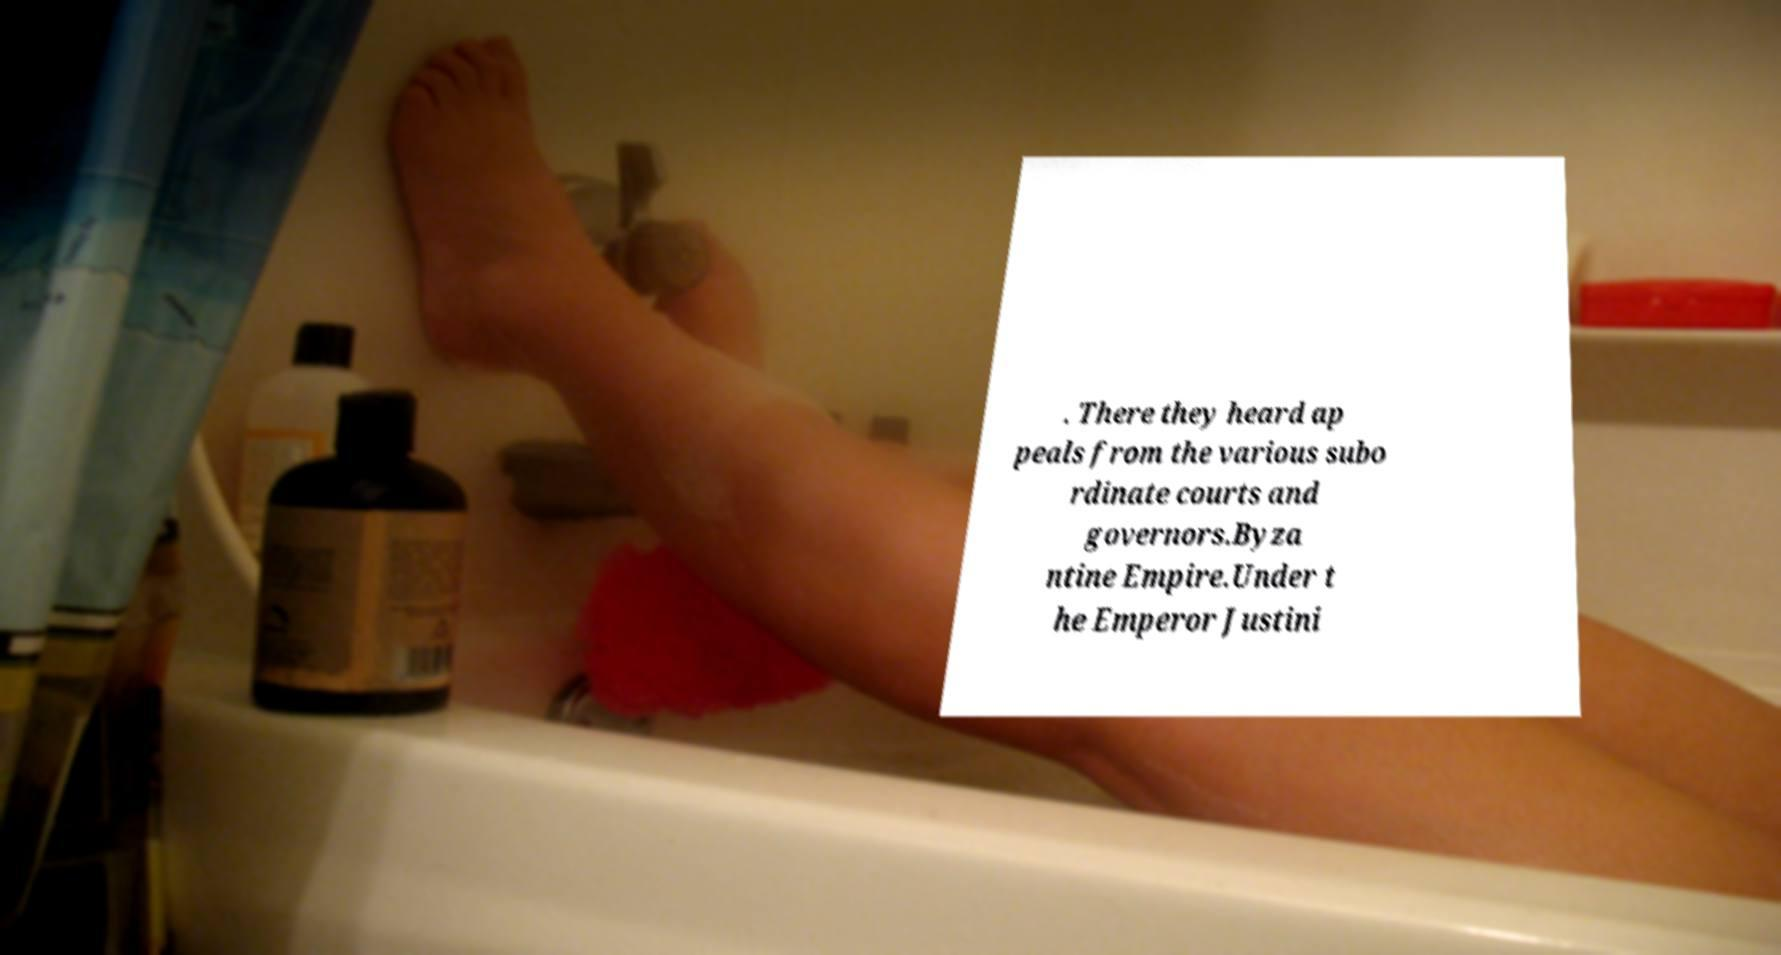There's text embedded in this image that I need extracted. Can you transcribe it verbatim? . There they heard ap peals from the various subo rdinate courts and governors.Byza ntine Empire.Under t he Emperor Justini 